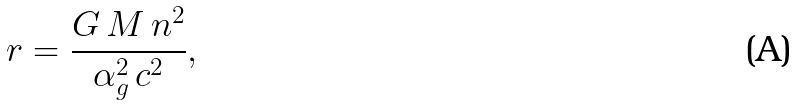Convert formula to latex. <formula><loc_0><loc_0><loc_500><loc_500>r = \frac { G \, M \, n ^ { 2 } } { \alpha _ { g } ^ { 2 } \, c ^ { 2 } } ,</formula> 